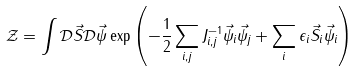Convert formula to latex. <formula><loc_0><loc_0><loc_500><loc_500>\, \mathcal { Z } = \int \mathcal { D } \vec { S } \mathcal { D } \vec { \psi } \exp \left ( - \frac { 1 } { 2 } \sum _ { i , j } J ^ { - 1 } _ { i , j } \vec { \psi } _ { i } \vec { \psi } _ { j } + \sum _ { i } \epsilon _ { i } \vec { S } _ { i } \vec { \psi } _ { i } \right )</formula> 